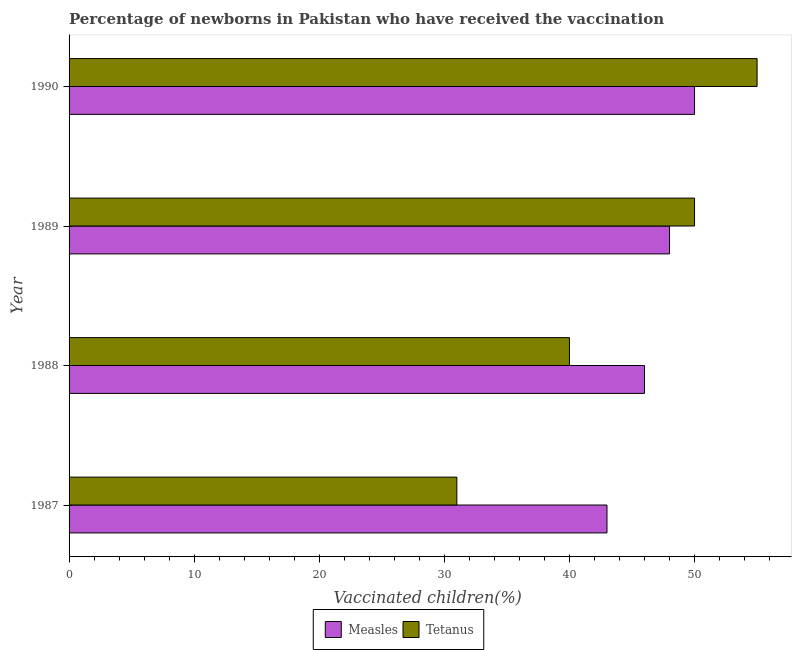How many different coloured bars are there?
Provide a short and direct response. 2. How many groups of bars are there?
Offer a terse response. 4. Are the number of bars on each tick of the Y-axis equal?
Give a very brief answer. Yes. How many bars are there on the 1st tick from the top?
Ensure brevity in your answer.  2. How many bars are there on the 3rd tick from the bottom?
Ensure brevity in your answer.  2. What is the percentage of newborns who received vaccination for measles in 1987?
Make the answer very short. 43. Across all years, what is the maximum percentage of newborns who received vaccination for measles?
Give a very brief answer. 50. Across all years, what is the minimum percentage of newborns who received vaccination for measles?
Ensure brevity in your answer.  43. What is the total percentage of newborns who received vaccination for tetanus in the graph?
Provide a succinct answer. 176. What is the difference between the percentage of newborns who received vaccination for measles in 1987 and that in 1990?
Offer a very short reply. -7. What is the difference between the percentage of newborns who received vaccination for tetanus in 1987 and the percentage of newborns who received vaccination for measles in 1988?
Your answer should be compact. -15. What is the average percentage of newborns who received vaccination for measles per year?
Make the answer very short. 46.75. In the year 1988, what is the difference between the percentage of newborns who received vaccination for measles and percentage of newborns who received vaccination for tetanus?
Provide a succinct answer. 6. What is the ratio of the percentage of newborns who received vaccination for tetanus in 1988 to that in 1990?
Ensure brevity in your answer.  0.73. What is the difference between the highest and the second highest percentage of newborns who received vaccination for tetanus?
Keep it short and to the point. 5. What is the difference between the highest and the lowest percentage of newborns who received vaccination for measles?
Ensure brevity in your answer.  7. What does the 2nd bar from the top in 1987 represents?
Your answer should be compact. Measles. What does the 2nd bar from the bottom in 1988 represents?
Your answer should be compact. Tetanus. How many bars are there?
Keep it short and to the point. 8. What is the difference between two consecutive major ticks on the X-axis?
Give a very brief answer. 10. Does the graph contain any zero values?
Provide a short and direct response. No. Does the graph contain grids?
Give a very brief answer. No. How are the legend labels stacked?
Make the answer very short. Horizontal. What is the title of the graph?
Offer a very short reply. Percentage of newborns in Pakistan who have received the vaccination. What is the label or title of the X-axis?
Give a very brief answer. Vaccinated children(%)
. What is the Vaccinated children(%)
 in Measles in 1987?
Ensure brevity in your answer.  43. What is the Vaccinated children(%)
 of Tetanus in 1987?
Provide a succinct answer. 31. What is the Vaccinated children(%)
 of Measles in 1989?
Ensure brevity in your answer.  48. What is the Vaccinated children(%)
 of Tetanus in 1989?
Keep it short and to the point. 50. What is the Vaccinated children(%)
 in Measles in 1990?
Offer a very short reply. 50. What is the total Vaccinated children(%)
 of Measles in the graph?
Provide a succinct answer. 187. What is the total Vaccinated children(%)
 in Tetanus in the graph?
Your answer should be very brief. 176. What is the difference between the Vaccinated children(%)
 in Tetanus in 1987 and that in 1988?
Your answer should be compact. -9. What is the difference between the Vaccinated children(%)
 in Measles in 1987 and that in 1989?
Give a very brief answer. -5. What is the difference between the Vaccinated children(%)
 of Tetanus in 1987 and that in 1989?
Ensure brevity in your answer.  -19. What is the difference between the Vaccinated children(%)
 in Tetanus in 1987 and that in 1990?
Keep it short and to the point. -24. What is the difference between the Vaccinated children(%)
 in Measles in 1989 and that in 1990?
Your answer should be very brief. -2. What is the difference between the Vaccinated children(%)
 in Tetanus in 1989 and that in 1990?
Your answer should be compact. -5. What is the difference between the Vaccinated children(%)
 in Measles in 1987 and the Vaccinated children(%)
 in Tetanus in 1988?
Provide a succinct answer. 3. What is the difference between the Vaccinated children(%)
 of Measles in 1987 and the Vaccinated children(%)
 of Tetanus in 1989?
Provide a short and direct response. -7. What is the difference between the Vaccinated children(%)
 of Measles in 1988 and the Vaccinated children(%)
 of Tetanus in 1990?
Ensure brevity in your answer.  -9. What is the difference between the Vaccinated children(%)
 of Measles in 1989 and the Vaccinated children(%)
 of Tetanus in 1990?
Your answer should be very brief. -7. What is the average Vaccinated children(%)
 of Measles per year?
Ensure brevity in your answer.  46.75. What is the average Vaccinated children(%)
 of Tetanus per year?
Make the answer very short. 44. In the year 1987, what is the difference between the Vaccinated children(%)
 of Measles and Vaccinated children(%)
 of Tetanus?
Your answer should be very brief. 12. In the year 1989, what is the difference between the Vaccinated children(%)
 of Measles and Vaccinated children(%)
 of Tetanus?
Provide a succinct answer. -2. In the year 1990, what is the difference between the Vaccinated children(%)
 in Measles and Vaccinated children(%)
 in Tetanus?
Offer a terse response. -5. What is the ratio of the Vaccinated children(%)
 in Measles in 1987 to that in 1988?
Give a very brief answer. 0.93. What is the ratio of the Vaccinated children(%)
 of Tetanus in 1987 to that in 1988?
Ensure brevity in your answer.  0.78. What is the ratio of the Vaccinated children(%)
 of Measles in 1987 to that in 1989?
Ensure brevity in your answer.  0.9. What is the ratio of the Vaccinated children(%)
 of Tetanus in 1987 to that in 1989?
Ensure brevity in your answer.  0.62. What is the ratio of the Vaccinated children(%)
 of Measles in 1987 to that in 1990?
Offer a very short reply. 0.86. What is the ratio of the Vaccinated children(%)
 in Tetanus in 1987 to that in 1990?
Ensure brevity in your answer.  0.56. What is the ratio of the Vaccinated children(%)
 in Measles in 1988 to that in 1989?
Your answer should be very brief. 0.96. What is the ratio of the Vaccinated children(%)
 in Tetanus in 1988 to that in 1989?
Keep it short and to the point. 0.8. What is the ratio of the Vaccinated children(%)
 of Measles in 1988 to that in 1990?
Keep it short and to the point. 0.92. What is the ratio of the Vaccinated children(%)
 of Tetanus in 1988 to that in 1990?
Your answer should be compact. 0.73. What is the ratio of the Vaccinated children(%)
 of Measles in 1989 to that in 1990?
Ensure brevity in your answer.  0.96. What is the difference between the highest and the second highest Vaccinated children(%)
 in Measles?
Offer a terse response. 2. What is the difference between the highest and the second highest Vaccinated children(%)
 in Tetanus?
Your answer should be very brief. 5. What is the difference between the highest and the lowest Vaccinated children(%)
 in Measles?
Provide a short and direct response. 7. What is the difference between the highest and the lowest Vaccinated children(%)
 in Tetanus?
Your response must be concise. 24. 